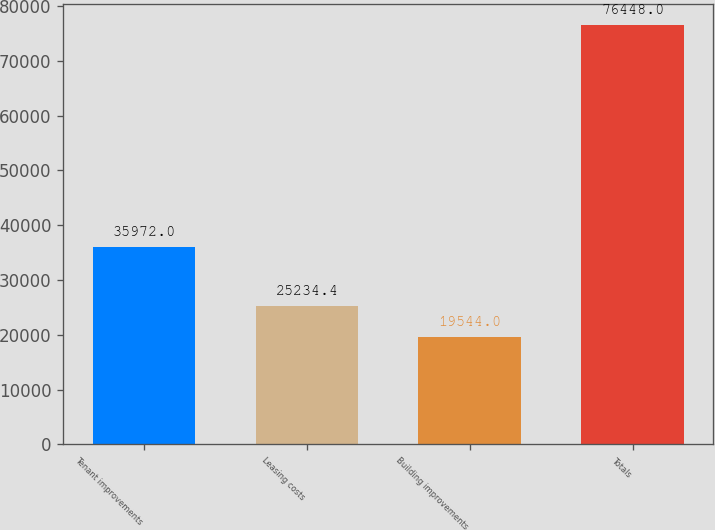Convert chart. <chart><loc_0><loc_0><loc_500><loc_500><bar_chart><fcel>Tenant improvements<fcel>Leasing costs<fcel>Building improvements<fcel>Totals<nl><fcel>35972<fcel>25234.4<fcel>19544<fcel>76448<nl></chart> 